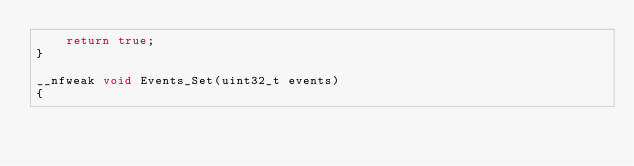<code> <loc_0><loc_0><loc_500><loc_500><_C++_>    return true;
}

__nfweak void Events_Set(uint32_t events)
{</code> 